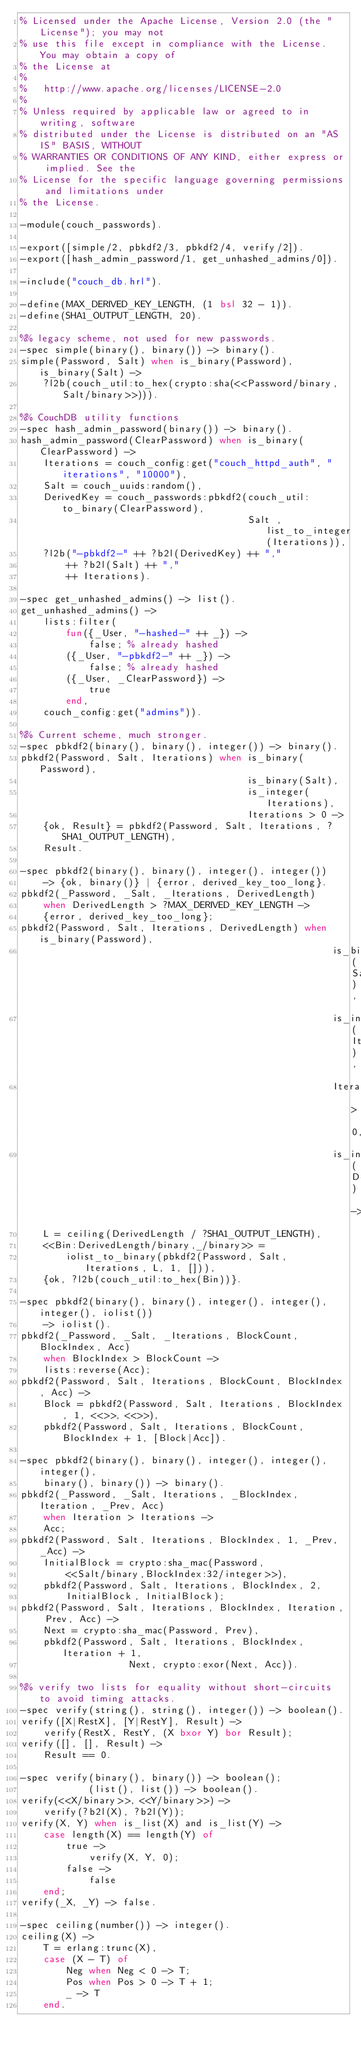<code> <loc_0><loc_0><loc_500><loc_500><_Erlang_>% Licensed under the Apache License, Version 2.0 (the "License"); you may not
% use this file except in compliance with the License. You may obtain a copy of
% the License at
%
%   http://www.apache.org/licenses/LICENSE-2.0
%
% Unless required by applicable law or agreed to in writing, software
% distributed under the License is distributed on an "AS IS" BASIS, WITHOUT
% WARRANTIES OR CONDITIONS OF ANY KIND, either express or implied. See the
% License for the specific language governing permissions and limitations under
% the License.

-module(couch_passwords).

-export([simple/2, pbkdf2/3, pbkdf2/4, verify/2]).
-export([hash_admin_password/1, get_unhashed_admins/0]).

-include("couch_db.hrl").

-define(MAX_DERIVED_KEY_LENGTH, (1 bsl 32 - 1)).
-define(SHA1_OUTPUT_LENGTH, 20).

%% legacy scheme, not used for new passwords.
-spec simple(binary(), binary()) -> binary().
simple(Password, Salt) when is_binary(Password), is_binary(Salt) ->
    ?l2b(couch_util:to_hex(crypto:sha(<<Password/binary, Salt/binary>>))).

%% CouchDB utility functions
-spec hash_admin_password(binary()) -> binary().
hash_admin_password(ClearPassword) when is_binary(ClearPassword) ->
    Iterations = couch_config:get("couch_httpd_auth", "iterations", "10000"),
    Salt = couch_uuids:random(),
    DerivedKey = couch_passwords:pbkdf2(couch_util:to_binary(ClearPassword),
                                        Salt ,list_to_integer(Iterations)),
    ?l2b("-pbkdf2-" ++ ?b2l(DerivedKey) ++ ","
        ++ ?b2l(Salt) ++ ","
        ++ Iterations).

-spec get_unhashed_admins() -> list().
get_unhashed_admins() ->
    lists:filter(
        fun({_User, "-hashed-" ++ _}) ->
            false; % already hashed
        ({_User, "-pbkdf2-" ++ _}) ->
            false; % already hashed
        ({_User, _ClearPassword}) ->
            true
        end,
    couch_config:get("admins")).

%% Current scheme, much stronger.
-spec pbkdf2(binary(), binary(), integer()) -> binary().
pbkdf2(Password, Salt, Iterations) when is_binary(Password),
                                        is_binary(Salt),
                                        is_integer(Iterations),
                                        Iterations > 0 ->
    {ok, Result} = pbkdf2(Password, Salt, Iterations, ?SHA1_OUTPUT_LENGTH),
    Result.

-spec pbkdf2(binary(), binary(), integer(), integer())
    -> {ok, binary()} | {error, derived_key_too_long}.
pbkdf2(_Password, _Salt, _Iterations, DerivedLength)
    when DerivedLength > ?MAX_DERIVED_KEY_LENGTH ->
    {error, derived_key_too_long};
pbkdf2(Password, Salt, Iterations, DerivedLength) when is_binary(Password),
                                                       is_binary(Salt),
                                                       is_integer(Iterations),
                                                       Iterations > 0,
                                                       is_integer(DerivedLength) ->
    L = ceiling(DerivedLength / ?SHA1_OUTPUT_LENGTH),
    <<Bin:DerivedLength/binary,_/binary>> =
        iolist_to_binary(pbkdf2(Password, Salt, Iterations, L, 1, [])),
    {ok, ?l2b(couch_util:to_hex(Bin))}.

-spec pbkdf2(binary(), binary(), integer(), integer(), integer(), iolist())
    -> iolist().
pbkdf2(_Password, _Salt, _Iterations, BlockCount, BlockIndex, Acc)
    when BlockIndex > BlockCount ->
    lists:reverse(Acc);
pbkdf2(Password, Salt, Iterations, BlockCount, BlockIndex, Acc) ->
    Block = pbkdf2(Password, Salt, Iterations, BlockIndex, 1, <<>>, <<>>),
    pbkdf2(Password, Salt, Iterations, BlockCount, BlockIndex + 1, [Block|Acc]).

-spec pbkdf2(binary(), binary(), integer(), integer(), integer(),
    binary(), binary()) -> binary().
pbkdf2(_Password, _Salt, Iterations, _BlockIndex, Iteration, _Prev, Acc)
    when Iteration > Iterations ->
    Acc;
pbkdf2(Password, Salt, Iterations, BlockIndex, 1, _Prev, _Acc) ->
    InitialBlock = crypto:sha_mac(Password,
        <<Salt/binary,BlockIndex:32/integer>>),
    pbkdf2(Password, Salt, Iterations, BlockIndex, 2,
        InitialBlock, InitialBlock);
pbkdf2(Password, Salt, Iterations, BlockIndex, Iteration, Prev, Acc) ->
    Next = crypto:sha_mac(Password, Prev),
    pbkdf2(Password, Salt, Iterations, BlockIndex, Iteration + 1,
                   Next, crypto:exor(Next, Acc)).

%% verify two lists for equality without short-circuits to avoid timing attacks.
-spec verify(string(), string(), integer()) -> boolean().
verify([X|RestX], [Y|RestY], Result) ->
    verify(RestX, RestY, (X bxor Y) bor Result);
verify([], [], Result) ->
    Result == 0.

-spec verify(binary(), binary()) -> boolean();
            (list(), list()) -> boolean().
verify(<<X/binary>>, <<Y/binary>>) ->
    verify(?b2l(X), ?b2l(Y));
verify(X, Y) when is_list(X) and is_list(Y) ->
    case length(X) == length(Y) of
        true ->
            verify(X, Y, 0);
        false ->
            false
    end;
verify(_X, _Y) -> false.

-spec ceiling(number()) -> integer().
ceiling(X) ->
    T = erlang:trunc(X),
    case (X - T) of
        Neg when Neg < 0 -> T;
        Pos when Pos > 0 -> T + 1;
        _ -> T
    end.
</code> 